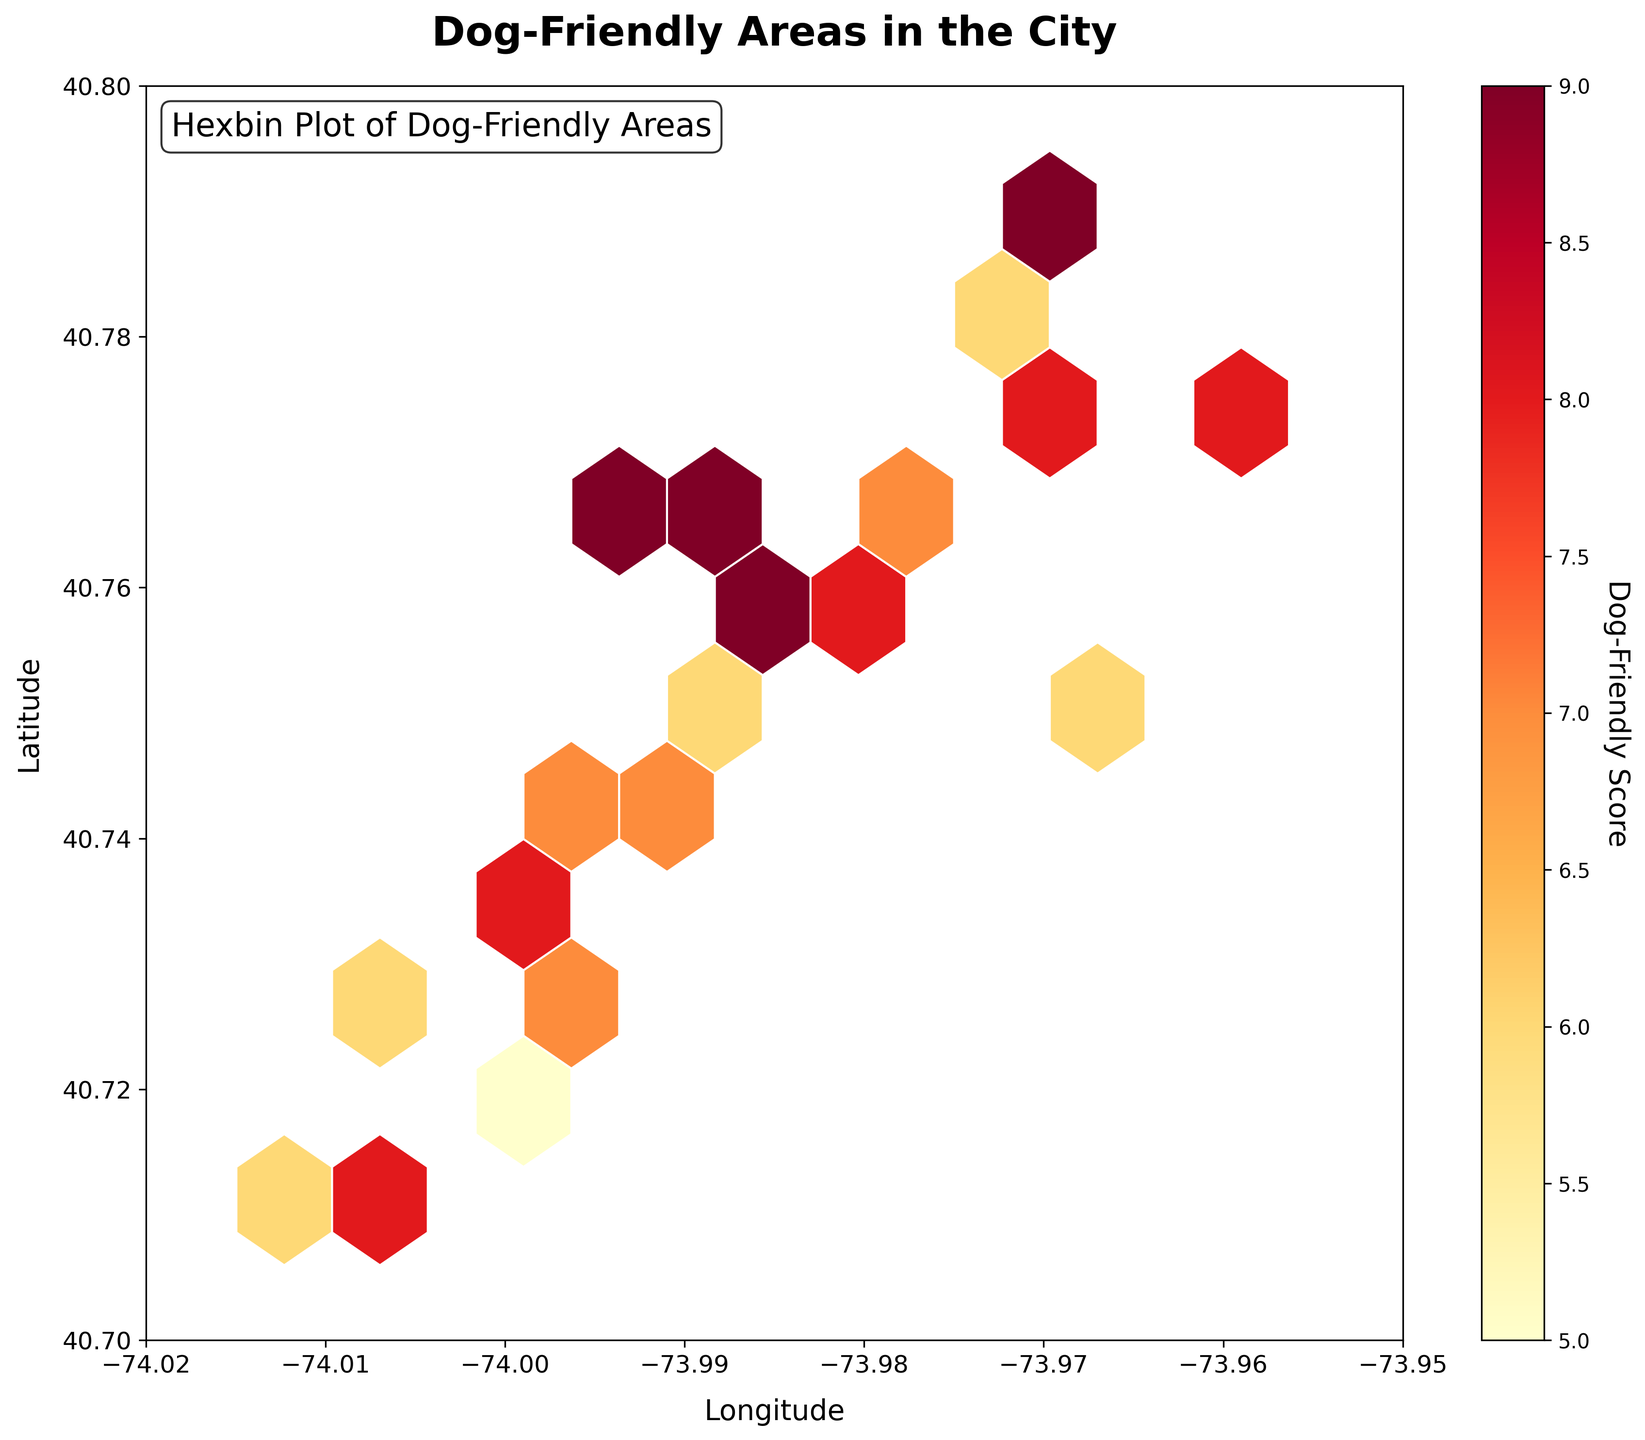What is the title of the figure? The title is the text located at the top of the figure. It provides an overview of the plot's subject.
Answer: Dog-Friendly Areas in the City What does the color bar represent? The color bar on the side of the figure often represents a numerical range linked to the color coding used in the plot. Here, it signifies the dog-friendly score.
Answer: Dog-Friendly Score How is the intensity of hexagons related to the data? The color intensity of hexagons changes based on the aggregated dog-friendly score within each hexagon. Brighter colors indicate higher scores.
Answer: Higher dog-friendly scores What are the ranges for longitude and latitude in the figure? The x-axis and y-axis labels indicate the ranges. The longitude ranges from -74.02 to -73.95, while the latitude ranges from 40.70 to 40.80.
Answer: Longitude: -74.02 to -73.95, Latitude: 40.70 to 40.80 Which general area (latitude and longitude) appears to be the most dog-friendly? By identifying the brighest colored hexagons in the plot, we can determine the most dog-friendly area. This appears near the coordinates where brighter hexagons are clustered.
Answer: Around latitude 40.76 and longitude -73.97 Is there any particular trend or pattern observable in the geographic distribution of dog-friendly areas? Observing any clustering or spreading of hexagons with higher scores can indicate a trend. Clusters of bright hexagons could indicate concentrated dog-friendly areas.
Answer: Clusters are present, indicating concentrated dog-friendly areas Between latitudes 40.74 and 40.78, which longitude range has higher dog-friendly scores? By focusing on the hexagons within the given latitude range, we observe the colors. The brighter hexagons indicate higher scores.
Answer: Around -73.98 What is the dog-friendly score represented by the brightest hexagon? The color bar indicates the range of dog-friendly scores. The hexagon with the brightest color can be compared to the color bar's highest value.
Answer: 9 Which part of the city has relatively lower dog-friendly scores, based on the color distribution? Darker hexagons indicate lower scores. Finding areas with more dark hexagons helps determine the less dog-friendly parts.
Answer: Around latitude 40.71 and longitude -74.01 Where do you see a lower concentration of hexagons, and what might this indicate? Areas with fewer hexagons might indicate fewer data points or parks. Observing any less-filled areas in the plot highlights these regions.
Answer: South-western part, indicating fewer parks 